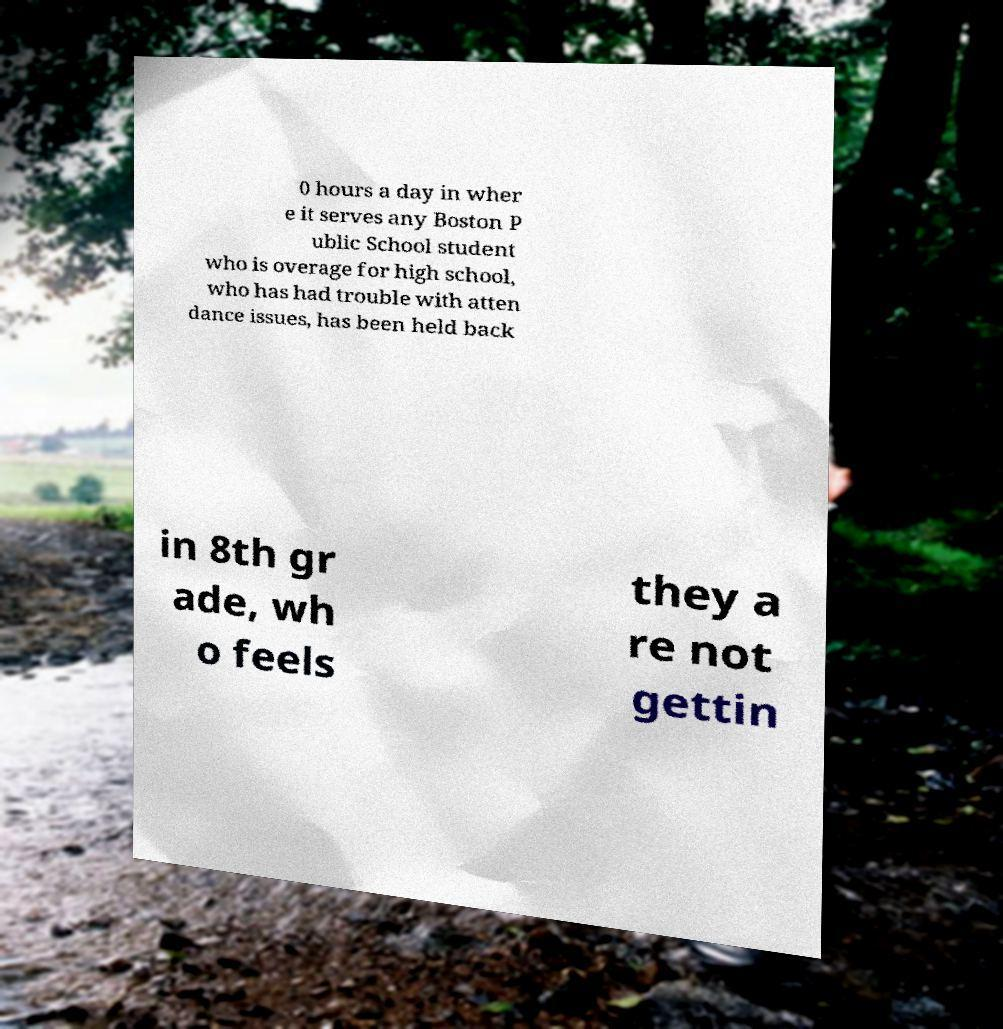For documentation purposes, I need the text within this image transcribed. Could you provide that? 0 hours a day in wher e it serves any Boston P ublic School student who is overage for high school, who has had trouble with atten dance issues, has been held back in 8th gr ade, wh o feels they a re not gettin 